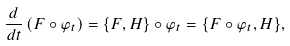<formula> <loc_0><loc_0><loc_500><loc_500>\frac { d } { d t } \left ( F \circ { \varphi } _ { t } \right ) = \{ F , H \} \circ { \varphi } _ { t } = \{ F \circ { \varphi } _ { t } , H \} ,</formula> 